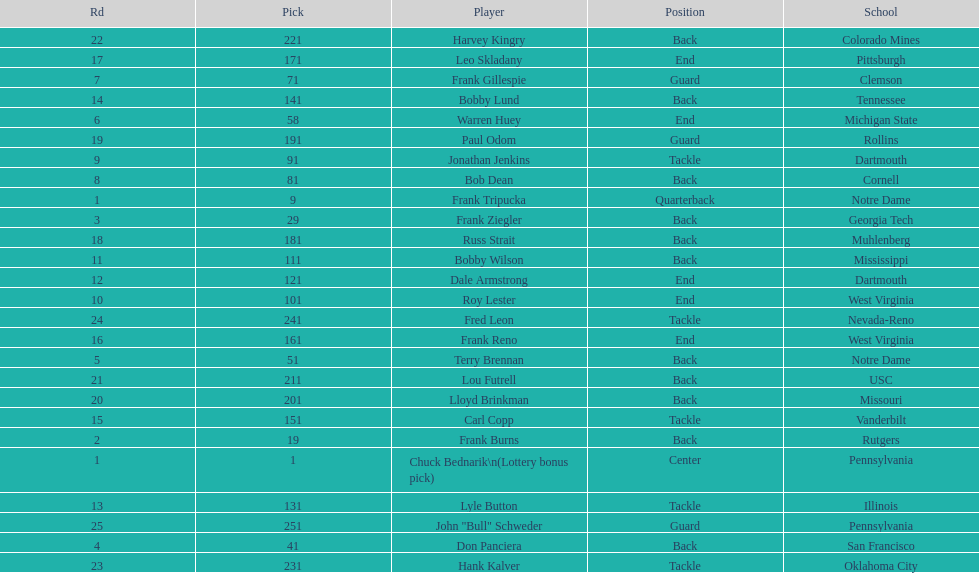Most prevalent school Pennsylvania. 